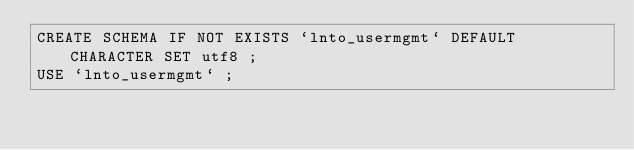<code> <loc_0><loc_0><loc_500><loc_500><_SQL_>CREATE SCHEMA IF NOT EXISTS `lnto_usermgmt` DEFAULT CHARACTER SET utf8 ;
USE `lnto_usermgmt` ;
</code> 